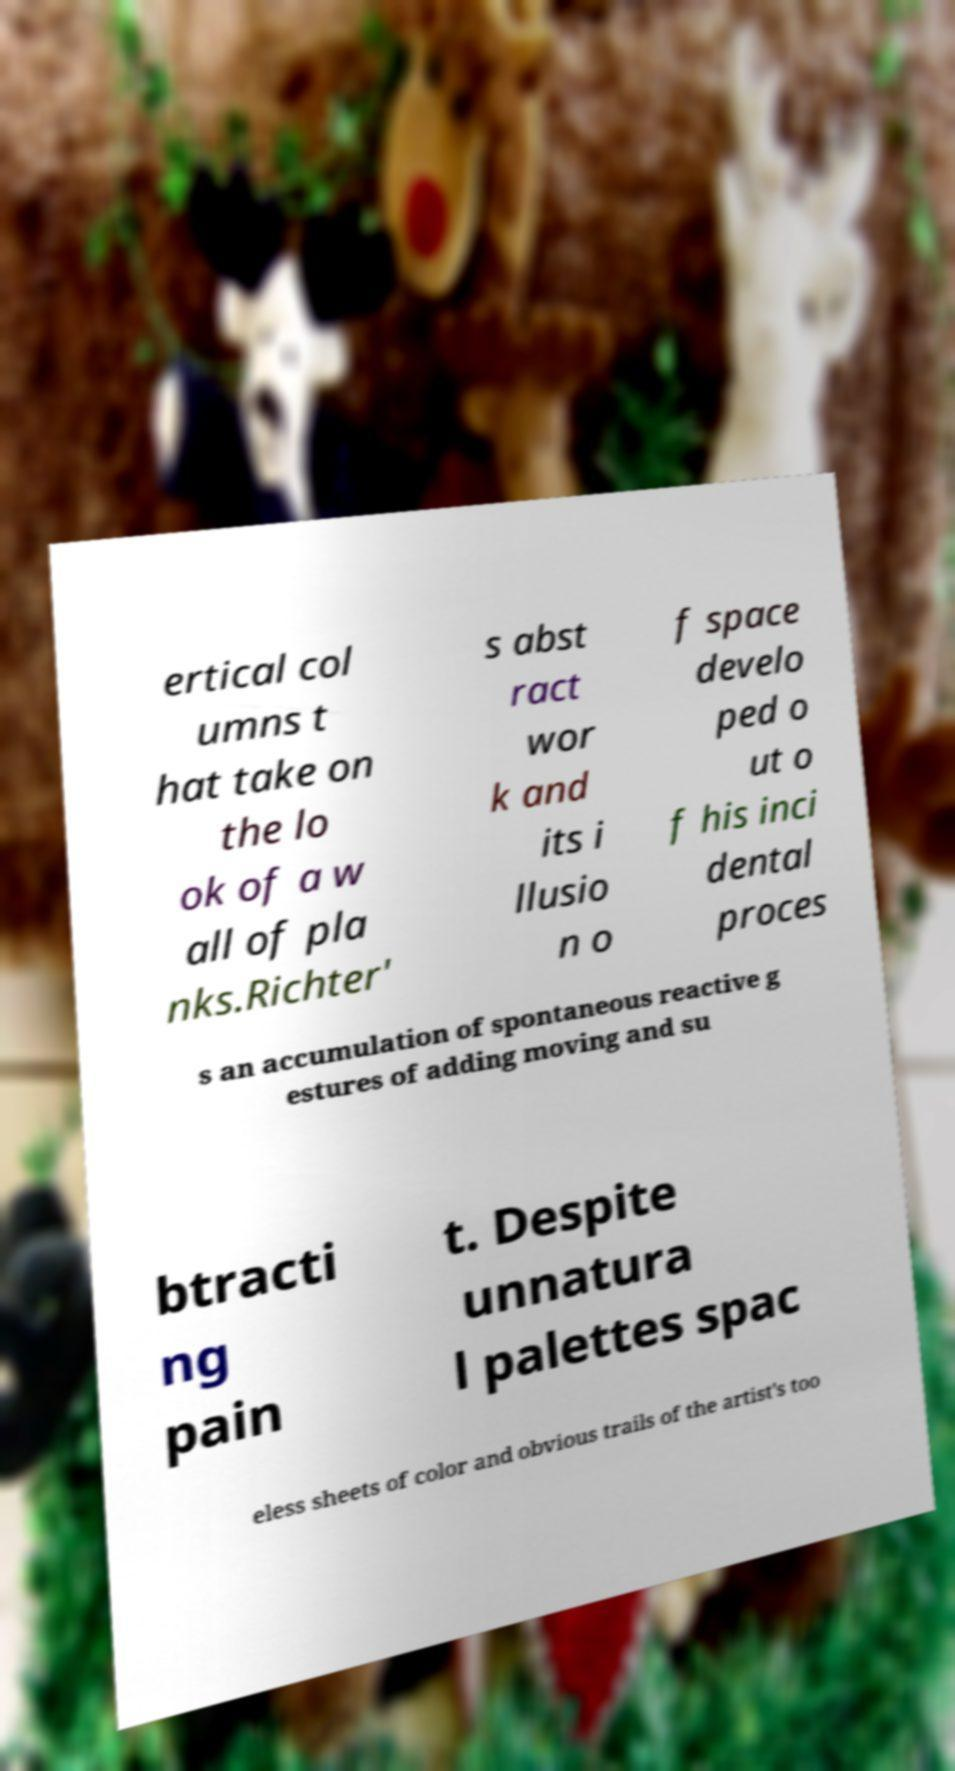Please identify and transcribe the text found in this image. ertical col umns t hat take on the lo ok of a w all of pla nks.Richter' s abst ract wor k and its i llusio n o f space develo ped o ut o f his inci dental proces s an accumulation of spontaneous reactive g estures of adding moving and su btracti ng pain t. Despite unnatura l palettes spac eless sheets of color and obvious trails of the artist's too 